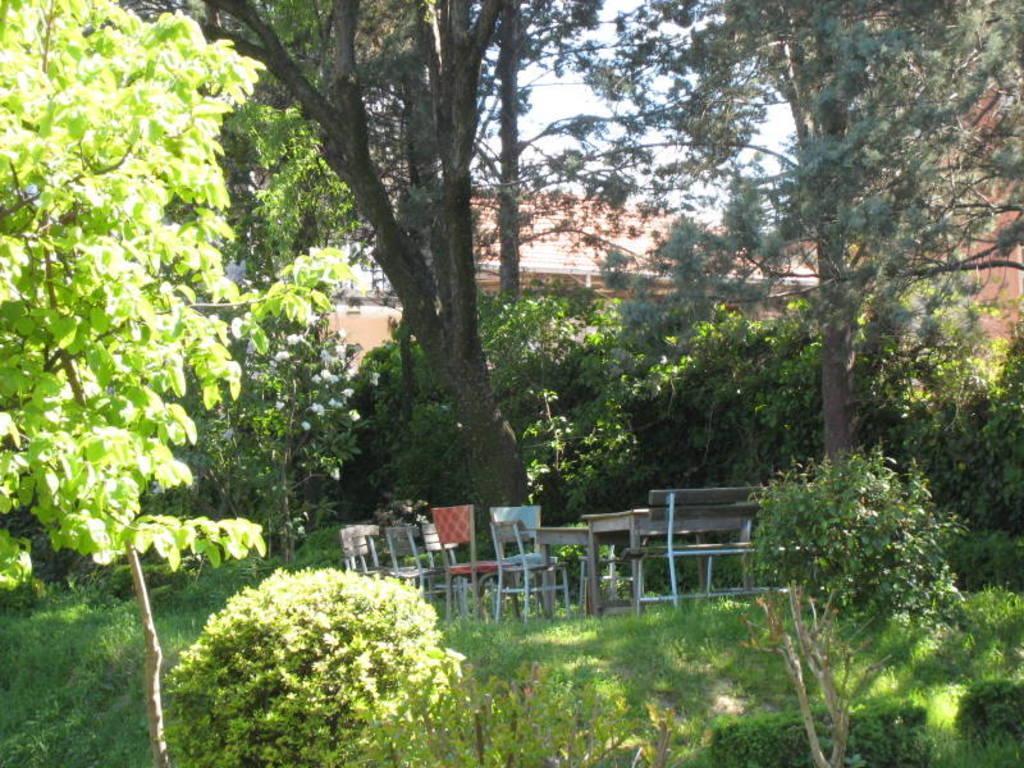In one or two sentences, can you explain what this image depicts? In this image we can see plants and trees. In the middle of the image table and chairs are there. Background of the image one house is present. 